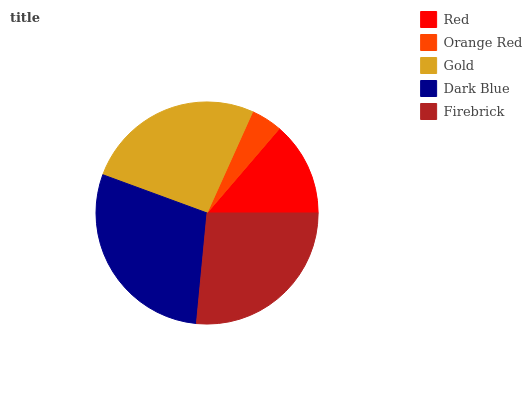Is Orange Red the minimum?
Answer yes or no. Yes. Is Dark Blue the maximum?
Answer yes or no. Yes. Is Gold the minimum?
Answer yes or no. No. Is Gold the maximum?
Answer yes or no. No. Is Gold greater than Orange Red?
Answer yes or no. Yes. Is Orange Red less than Gold?
Answer yes or no. Yes. Is Orange Red greater than Gold?
Answer yes or no. No. Is Gold less than Orange Red?
Answer yes or no. No. Is Gold the high median?
Answer yes or no. Yes. Is Gold the low median?
Answer yes or no. Yes. Is Red the high median?
Answer yes or no. No. Is Firebrick the low median?
Answer yes or no. No. 